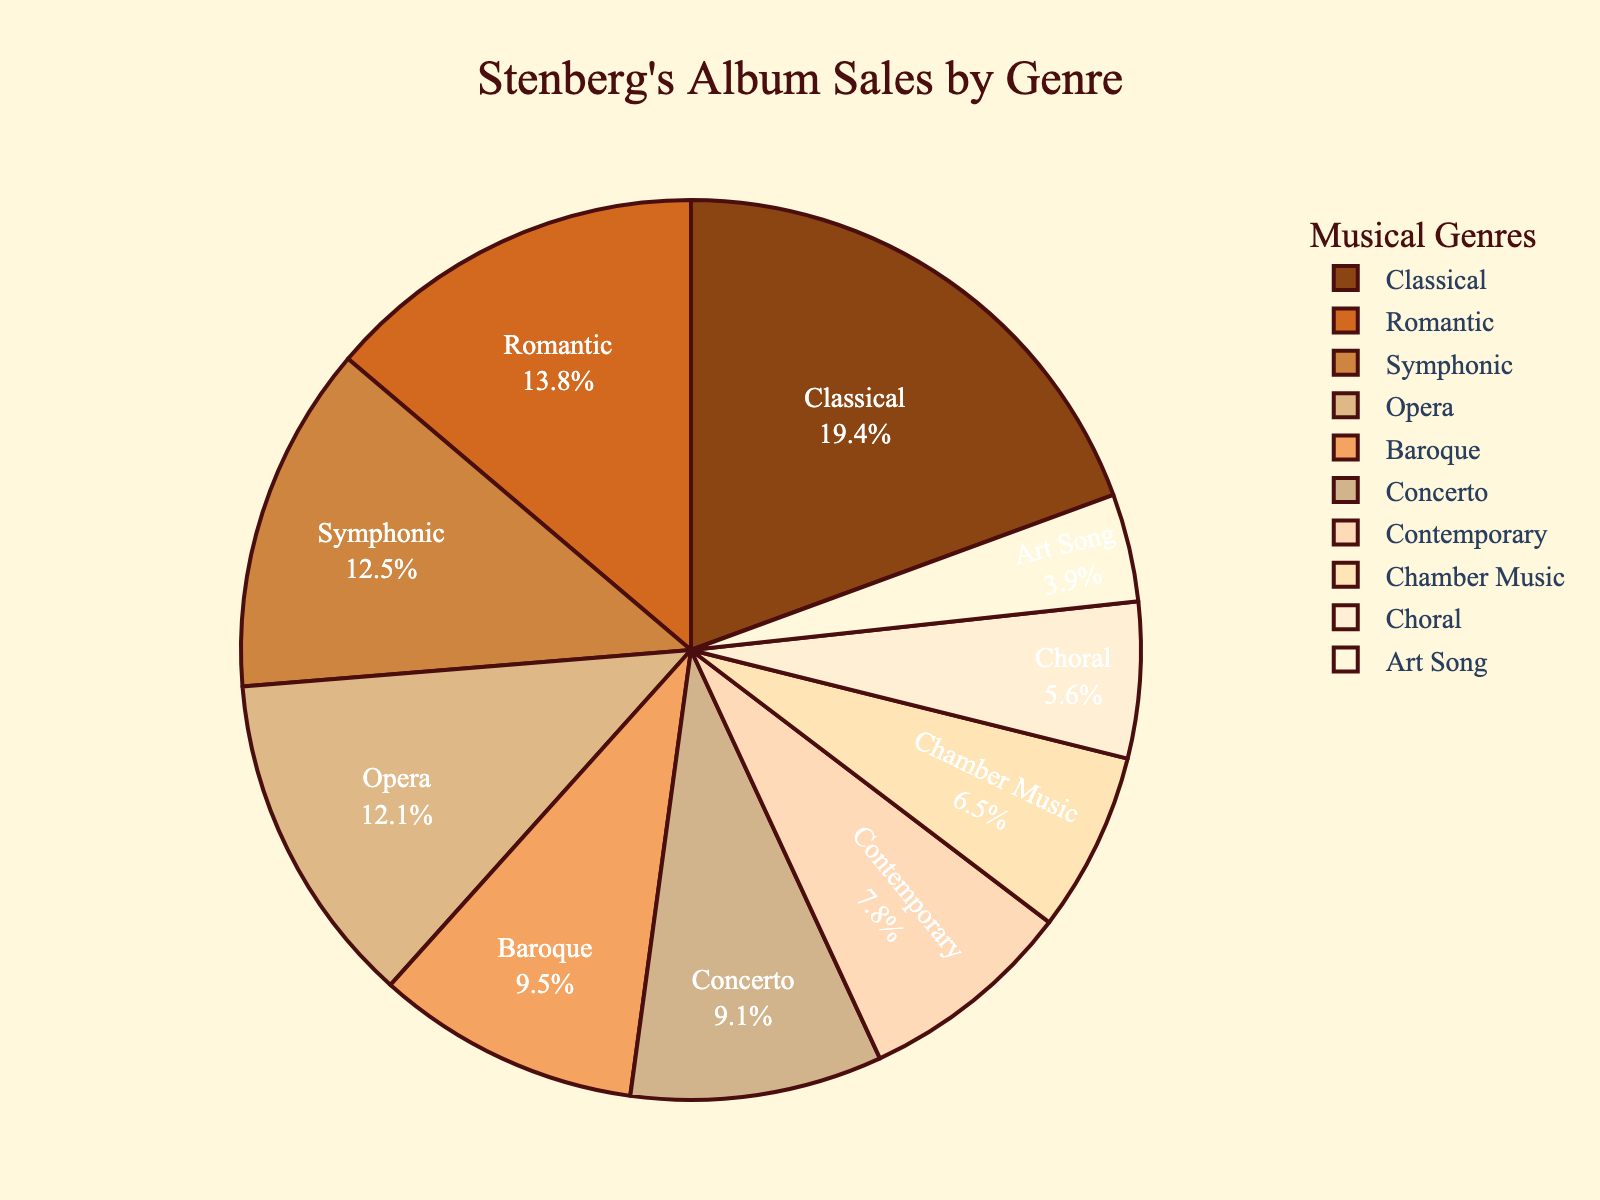What genre has the highest sales? The pie chart shows the sales for each genre, and the largest segment corresponds to Classical music.
Answer: Classical Which genre has the lowest sales? The smallest segment in the pie chart represents Art Song, indicating it has the lowest sales.
Answer: Art Song How do the combined sales of Opera and Baroque compare to Classical? Adding the sales of Opera (280,000) and Baroque (220,000) gives a total of 500,000, which is higher than the sales for Classical music (450,000).
Answer: Higher What is the total sales of Contemporary, Chamber Music, and Concerto combined? Adding the sales of Contemporary (180,000), Chamber Music (150,000), and Concerto (210,000) gives a total of 540,000.
Answer: 540,000 Among Symphonic, Concerto, and Choral, which genre has the highest sales? Comparing the sales values: Symphonic (290,000), Concerto (210,000), Choral (130,000), Symphonic has the highest sales.
Answer: Symphonic Does Romantic outsell Baroque and Choral combined? The sales for Romantic (320,000) is greater than the combined sales of Baroque (220,000) and Choral (130,000), totaling 350,000.
Answer: No What percentage of the total sales is contributed by Romantic music? The total sales are 2,320,000 (sum of all genres). The percentage contribution of Romantic music is (320,000 / 2,320,000) * 100 = 13.8%.
Answer: 13.8% How much more does Classical sell compared to Art Song? Subtracting the sales of Art Song (90,000) from Classical (450,000) gives 360,000.
Answer: 360,000 Which genre sales constitute more than 10% of the total album sales? Classical (450,000 / 2,320,000 = 19.4%), Opera (280,000 / 2,320,000 = 12.1%), Romantic (320,000 / 2,320,000 = 13.8%), and Symphonic (290,000 / 2,320,000 = 12.5%) each constitute more than 10%.
Answer: Classical, Opera, Romantic, Symphonic If you combine sales of all genres excluding Classical, does it surpass 1.8 million? Excluding Classical, the combined sales are 1,870,000 which is greater than 1.8 million.
Answer: Yes 